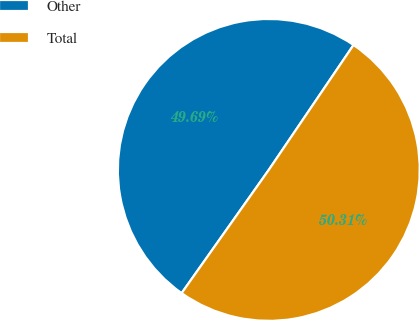Convert chart to OTSL. <chart><loc_0><loc_0><loc_500><loc_500><pie_chart><fcel>Other<fcel>Total<nl><fcel>49.69%<fcel>50.31%<nl></chart> 